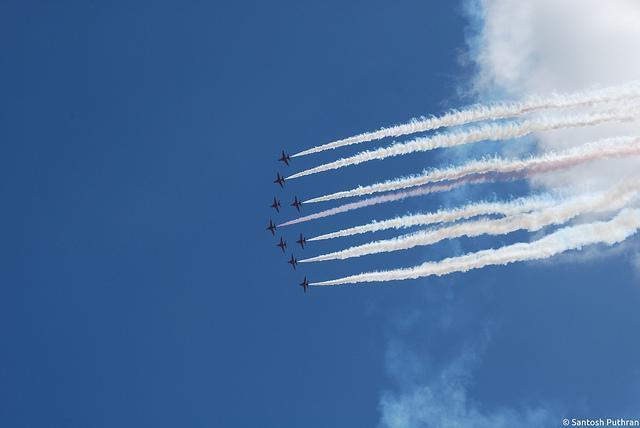How many jets are flying?
Give a very brief answer. 9. How many planes do you see?
Give a very brief answer. 9. How many people wearing white hat in the background?
Give a very brief answer. 0. 